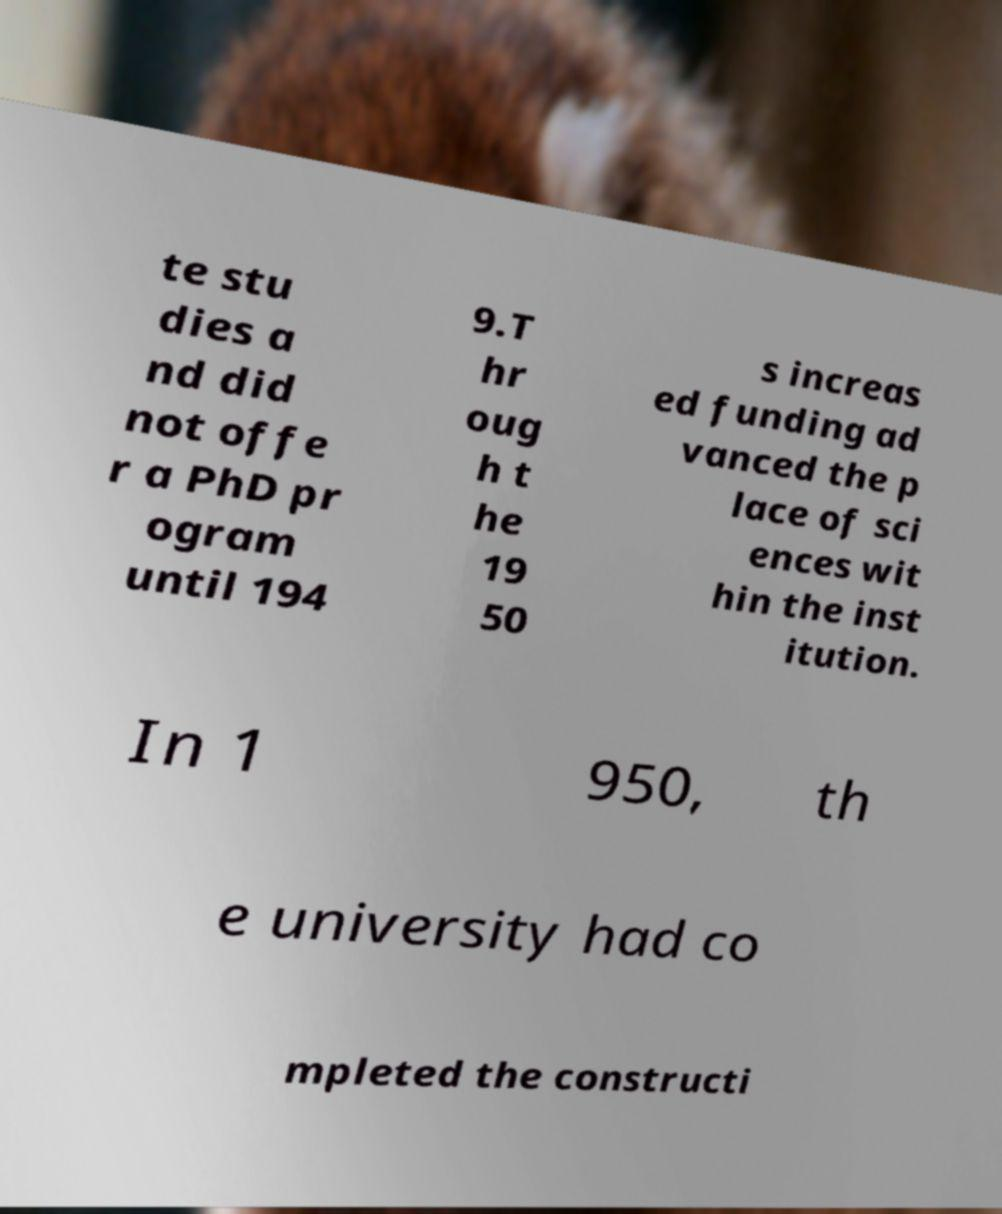There's text embedded in this image that I need extracted. Can you transcribe it verbatim? te stu dies a nd did not offe r a PhD pr ogram until 194 9.T hr oug h t he 19 50 s increas ed funding ad vanced the p lace of sci ences wit hin the inst itution. In 1 950, th e university had co mpleted the constructi 